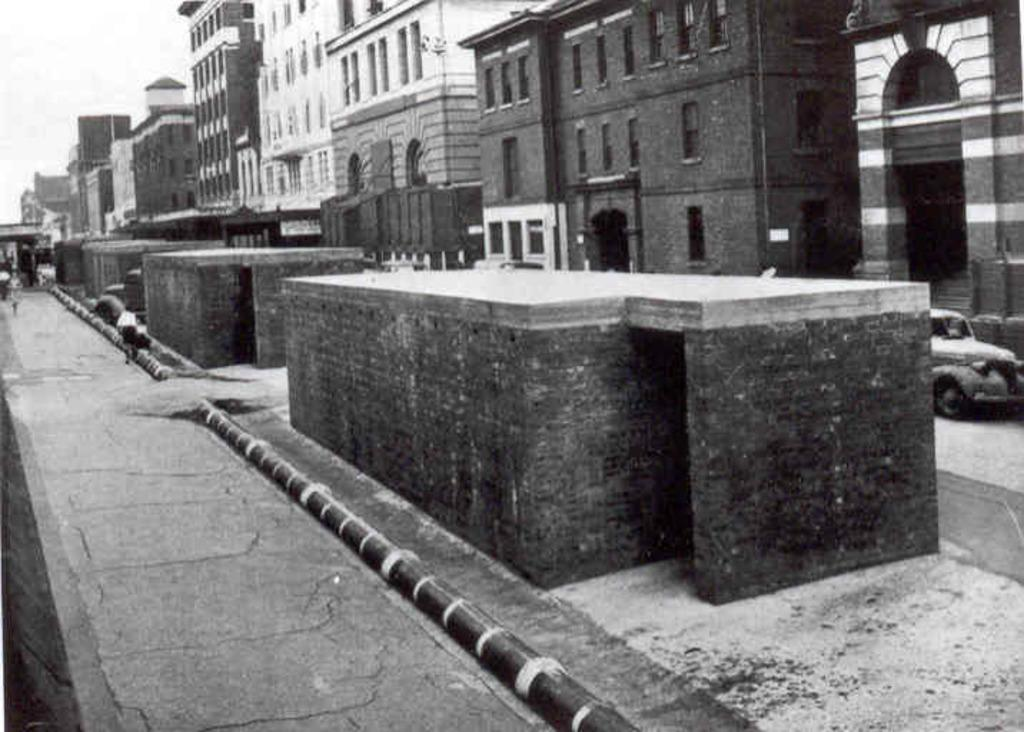What is the color scheme of the image? The image is black and white. What type of structures can be seen in the image? There are buildings in the image. What else is present on the ground in the image? There are vehicles on the ground in the image. What part of the natural environment is visible in the image? The sky is visible in the image. What time of day does the coach arrive in the image? There is no coach present in the image, so it is not possible to determine when a coach might arrive. 